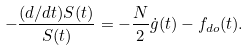<formula> <loc_0><loc_0><loc_500><loc_500>- \frac { ( d / d t ) S ( t ) } { S ( t ) } = - \frac { N } { 2 } \dot { g } ( t ) - f _ { d o } ( t ) .</formula> 